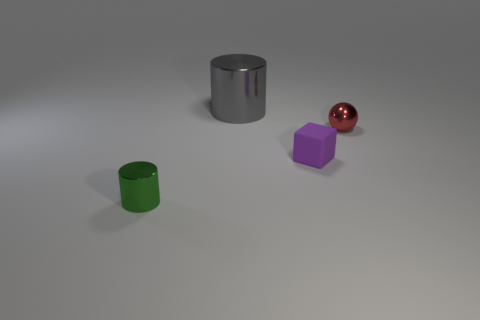What material is the small purple cube right of the small shiny object to the left of the small cube?
Keep it short and to the point. Rubber. There is a object that is both behind the small purple thing and to the right of the large gray metal object; what is its material?
Your response must be concise. Metal. Is there another rubber object of the same shape as the purple thing?
Ensure brevity in your answer.  No. There is a metal thing that is right of the gray thing; are there any blocks in front of it?
Make the answer very short. Yes. What number of green cylinders are the same material as the tiny sphere?
Provide a short and direct response. 1. Are any small green metal objects visible?
Give a very brief answer. Yes. What number of matte things have the same color as the tiny ball?
Make the answer very short. 0. Does the small green cylinder have the same material as the tiny thing that is to the right of the small purple matte object?
Make the answer very short. Yes. Are there more red things that are in front of the small red sphere than small things?
Your response must be concise. No. Is there anything else that has the same size as the gray shiny thing?
Offer a terse response. No. 